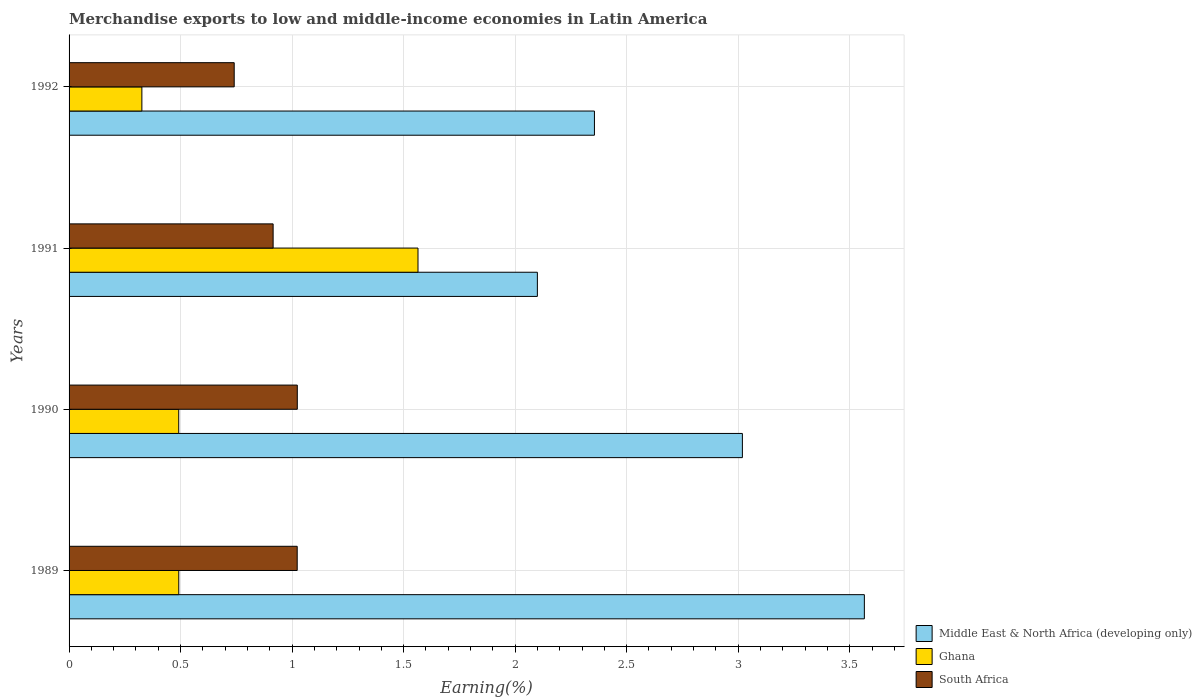Are the number of bars per tick equal to the number of legend labels?
Keep it short and to the point. Yes. Are the number of bars on each tick of the Y-axis equal?
Provide a succinct answer. Yes. How many bars are there on the 4th tick from the bottom?
Ensure brevity in your answer.  3. In how many cases, is the number of bars for a given year not equal to the number of legend labels?
Offer a terse response. 0. What is the percentage of amount earned from merchandise exports in South Africa in 1990?
Provide a short and direct response. 1.02. Across all years, what is the maximum percentage of amount earned from merchandise exports in South Africa?
Provide a succinct answer. 1.02. Across all years, what is the minimum percentage of amount earned from merchandise exports in Ghana?
Make the answer very short. 0.33. In which year was the percentage of amount earned from merchandise exports in South Africa maximum?
Provide a succinct answer. 1990. In which year was the percentage of amount earned from merchandise exports in Middle East & North Africa (developing only) minimum?
Make the answer very short. 1991. What is the total percentage of amount earned from merchandise exports in Ghana in the graph?
Ensure brevity in your answer.  2.87. What is the difference between the percentage of amount earned from merchandise exports in Middle East & North Africa (developing only) in 1989 and that in 1991?
Your answer should be compact. 1.47. What is the difference between the percentage of amount earned from merchandise exports in Ghana in 1992 and the percentage of amount earned from merchandise exports in South Africa in 1991?
Offer a very short reply. -0.59. What is the average percentage of amount earned from merchandise exports in Middle East & North Africa (developing only) per year?
Ensure brevity in your answer.  2.76. In the year 1992, what is the difference between the percentage of amount earned from merchandise exports in South Africa and percentage of amount earned from merchandise exports in Middle East & North Africa (developing only)?
Keep it short and to the point. -1.62. In how many years, is the percentage of amount earned from merchandise exports in Ghana greater than 3.3 %?
Provide a short and direct response. 0. What is the ratio of the percentage of amount earned from merchandise exports in Ghana in 1989 to that in 1990?
Provide a short and direct response. 1. Is the percentage of amount earned from merchandise exports in Ghana in 1989 less than that in 1992?
Make the answer very short. No. Is the difference between the percentage of amount earned from merchandise exports in South Africa in 1991 and 1992 greater than the difference between the percentage of amount earned from merchandise exports in Middle East & North Africa (developing only) in 1991 and 1992?
Your answer should be compact. Yes. What is the difference between the highest and the second highest percentage of amount earned from merchandise exports in South Africa?
Offer a very short reply. 0. What is the difference between the highest and the lowest percentage of amount earned from merchandise exports in South Africa?
Keep it short and to the point. 0.28. Is the sum of the percentage of amount earned from merchandise exports in Middle East & North Africa (developing only) in 1990 and 1991 greater than the maximum percentage of amount earned from merchandise exports in South Africa across all years?
Make the answer very short. Yes. What does the 1st bar from the top in 1990 represents?
Your answer should be compact. South Africa. What does the 3rd bar from the bottom in 1992 represents?
Offer a terse response. South Africa. Is it the case that in every year, the sum of the percentage of amount earned from merchandise exports in Ghana and percentage of amount earned from merchandise exports in Middle East & North Africa (developing only) is greater than the percentage of amount earned from merchandise exports in South Africa?
Offer a very short reply. Yes. Are all the bars in the graph horizontal?
Your answer should be very brief. Yes. How are the legend labels stacked?
Your response must be concise. Vertical. What is the title of the graph?
Keep it short and to the point. Merchandise exports to low and middle-income economies in Latin America. Does "Ukraine" appear as one of the legend labels in the graph?
Ensure brevity in your answer.  No. What is the label or title of the X-axis?
Give a very brief answer. Earning(%). What is the label or title of the Y-axis?
Your response must be concise. Years. What is the Earning(%) in Middle East & North Africa (developing only) in 1989?
Give a very brief answer. 3.57. What is the Earning(%) of Ghana in 1989?
Make the answer very short. 0.49. What is the Earning(%) in South Africa in 1989?
Offer a very short reply. 1.02. What is the Earning(%) of Middle East & North Africa (developing only) in 1990?
Your answer should be very brief. 3.02. What is the Earning(%) of Ghana in 1990?
Provide a succinct answer. 0.49. What is the Earning(%) in South Africa in 1990?
Keep it short and to the point. 1.02. What is the Earning(%) of Middle East & North Africa (developing only) in 1991?
Provide a succinct answer. 2.1. What is the Earning(%) in Ghana in 1991?
Provide a short and direct response. 1.56. What is the Earning(%) of South Africa in 1991?
Keep it short and to the point. 0.91. What is the Earning(%) of Middle East & North Africa (developing only) in 1992?
Offer a terse response. 2.36. What is the Earning(%) in Ghana in 1992?
Provide a succinct answer. 0.33. What is the Earning(%) in South Africa in 1992?
Your answer should be compact. 0.74. Across all years, what is the maximum Earning(%) in Middle East & North Africa (developing only)?
Offer a terse response. 3.57. Across all years, what is the maximum Earning(%) in Ghana?
Keep it short and to the point. 1.56. Across all years, what is the maximum Earning(%) of South Africa?
Make the answer very short. 1.02. Across all years, what is the minimum Earning(%) in Middle East & North Africa (developing only)?
Provide a succinct answer. 2.1. Across all years, what is the minimum Earning(%) of Ghana?
Ensure brevity in your answer.  0.33. Across all years, what is the minimum Earning(%) in South Africa?
Give a very brief answer. 0.74. What is the total Earning(%) in Middle East & North Africa (developing only) in the graph?
Keep it short and to the point. 11.04. What is the total Earning(%) in Ghana in the graph?
Keep it short and to the point. 2.87. What is the total Earning(%) of South Africa in the graph?
Your answer should be very brief. 3.7. What is the difference between the Earning(%) in Middle East & North Africa (developing only) in 1989 and that in 1990?
Your answer should be very brief. 0.55. What is the difference between the Earning(%) of Ghana in 1989 and that in 1990?
Offer a very short reply. 0. What is the difference between the Earning(%) of South Africa in 1989 and that in 1990?
Keep it short and to the point. -0. What is the difference between the Earning(%) of Middle East & North Africa (developing only) in 1989 and that in 1991?
Offer a very short reply. 1.47. What is the difference between the Earning(%) of Ghana in 1989 and that in 1991?
Keep it short and to the point. -1.07. What is the difference between the Earning(%) in South Africa in 1989 and that in 1991?
Ensure brevity in your answer.  0.11. What is the difference between the Earning(%) of Middle East & North Africa (developing only) in 1989 and that in 1992?
Your answer should be very brief. 1.21. What is the difference between the Earning(%) in Ghana in 1989 and that in 1992?
Provide a short and direct response. 0.17. What is the difference between the Earning(%) of South Africa in 1989 and that in 1992?
Ensure brevity in your answer.  0.28. What is the difference between the Earning(%) of Middle East & North Africa (developing only) in 1990 and that in 1991?
Make the answer very short. 0.92. What is the difference between the Earning(%) in Ghana in 1990 and that in 1991?
Give a very brief answer. -1.07. What is the difference between the Earning(%) of South Africa in 1990 and that in 1991?
Keep it short and to the point. 0.11. What is the difference between the Earning(%) of Middle East & North Africa (developing only) in 1990 and that in 1992?
Provide a succinct answer. 0.66. What is the difference between the Earning(%) in Ghana in 1990 and that in 1992?
Provide a short and direct response. 0.17. What is the difference between the Earning(%) in South Africa in 1990 and that in 1992?
Provide a short and direct response. 0.28. What is the difference between the Earning(%) in Middle East & North Africa (developing only) in 1991 and that in 1992?
Make the answer very short. -0.26. What is the difference between the Earning(%) of Ghana in 1991 and that in 1992?
Make the answer very short. 1.24. What is the difference between the Earning(%) in South Africa in 1991 and that in 1992?
Ensure brevity in your answer.  0.17. What is the difference between the Earning(%) of Middle East & North Africa (developing only) in 1989 and the Earning(%) of Ghana in 1990?
Your answer should be very brief. 3.07. What is the difference between the Earning(%) in Middle East & North Africa (developing only) in 1989 and the Earning(%) in South Africa in 1990?
Provide a short and direct response. 2.54. What is the difference between the Earning(%) in Ghana in 1989 and the Earning(%) in South Africa in 1990?
Provide a short and direct response. -0.53. What is the difference between the Earning(%) of Middle East & North Africa (developing only) in 1989 and the Earning(%) of Ghana in 1991?
Keep it short and to the point. 2. What is the difference between the Earning(%) in Middle East & North Africa (developing only) in 1989 and the Earning(%) in South Africa in 1991?
Give a very brief answer. 2.65. What is the difference between the Earning(%) of Ghana in 1989 and the Earning(%) of South Africa in 1991?
Your answer should be compact. -0.42. What is the difference between the Earning(%) of Middle East & North Africa (developing only) in 1989 and the Earning(%) of Ghana in 1992?
Ensure brevity in your answer.  3.24. What is the difference between the Earning(%) in Middle East & North Africa (developing only) in 1989 and the Earning(%) in South Africa in 1992?
Offer a terse response. 2.83. What is the difference between the Earning(%) in Ghana in 1989 and the Earning(%) in South Africa in 1992?
Offer a very short reply. -0.25. What is the difference between the Earning(%) of Middle East & North Africa (developing only) in 1990 and the Earning(%) of Ghana in 1991?
Offer a terse response. 1.45. What is the difference between the Earning(%) in Middle East & North Africa (developing only) in 1990 and the Earning(%) in South Africa in 1991?
Provide a short and direct response. 2.1. What is the difference between the Earning(%) of Ghana in 1990 and the Earning(%) of South Africa in 1991?
Make the answer very short. -0.42. What is the difference between the Earning(%) in Middle East & North Africa (developing only) in 1990 and the Earning(%) in Ghana in 1992?
Keep it short and to the point. 2.69. What is the difference between the Earning(%) in Middle East & North Africa (developing only) in 1990 and the Earning(%) in South Africa in 1992?
Your answer should be compact. 2.28. What is the difference between the Earning(%) in Ghana in 1990 and the Earning(%) in South Africa in 1992?
Make the answer very short. -0.25. What is the difference between the Earning(%) of Middle East & North Africa (developing only) in 1991 and the Earning(%) of Ghana in 1992?
Offer a very short reply. 1.77. What is the difference between the Earning(%) in Middle East & North Africa (developing only) in 1991 and the Earning(%) in South Africa in 1992?
Provide a succinct answer. 1.36. What is the difference between the Earning(%) in Ghana in 1991 and the Earning(%) in South Africa in 1992?
Offer a very short reply. 0.82. What is the average Earning(%) of Middle East & North Africa (developing only) per year?
Offer a very short reply. 2.76. What is the average Earning(%) in Ghana per year?
Offer a terse response. 0.72. What is the average Earning(%) of South Africa per year?
Your answer should be compact. 0.93. In the year 1989, what is the difference between the Earning(%) in Middle East & North Africa (developing only) and Earning(%) in Ghana?
Provide a succinct answer. 3.07. In the year 1989, what is the difference between the Earning(%) of Middle East & North Africa (developing only) and Earning(%) of South Africa?
Your response must be concise. 2.54. In the year 1989, what is the difference between the Earning(%) of Ghana and Earning(%) of South Africa?
Offer a very short reply. -0.53. In the year 1990, what is the difference between the Earning(%) of Middle East & North Africa (developing only) and Earning(%) of Ghana?
Keep it short and to the point. 2.53. In the year 1990, what is the difference between the Earning(%) of Middle East & North Africa (developing only) and Earning(%) of South Africa?
Provide a succinct answer. 2. In the year 1990, what is the difference between the Earning(%) in Ghana and Earning(%) in South Africa?
Your response must be concise. -0.53. In the year 1991, what is the difference between the Earning(%) in Middle East & North Africa (developing only) and Earning(%) in Ghana?
Keep it short and to the point. 0.54. In the year 1991, what is the difference between the Earning(%) in Middle East & North Africa (developing only) and Earning(%) in South Africa?
Make the answer very short. 1.18. In the year 1991, what is the difference between the Earning(%) in Ghana and Earning(%) in South Africa?
Provide a succinct answer. 0.65. In the year 1992, what is the difference between the Earning(%) of Middle East & North Africa (developing only) and Earning(%) of Ghana?
Provide a short and direct response. 2.03. In the year 1992, what is the difference between the Earning(%) in Middle East & North Africa (developing only) and Earning(%) in South Africa?
Offer a terse response. 1.62. In the year 1992, what is the difference between the Earning(%) in Ghana and Earning(%) in South Africa?
Ensure brevity in your answer.  -0.41. What is the ratio of the Earning(%) of Middle East & North Africa (developing only) in 1989 to that in 1990?
Ensure brevity in your answer.  1.18. What is the ratio of the Earning(%) in Ghana in 1989 to that in 1990?
Offer a very short reply. 1. What is the ratio of the Earning(%) in Middle East & North Africa (developing only) in 1989 to that in 1991?
Provide a succinct answer. 1.7. What is the ratio of the Earning(%) in Ghana in 1989 to that in 1991?
Give a very brief answer. 0.31. What is the ratio of the Earning(%) in South Africa in 1989 to that in 1991?
Ensure brevity in your answer.  1.12. What is the ratio of the Earning(%) in Middle East & North Africa (developing only) in 1989 to that in 1992?
Your response must be concise. 1.51. What is the ratio of the Earning(%) of Ghana in 1989 to that in 1992?
Offer a very short reply. 1.51. What is the ratio of the Earning(%) of South Africa in 1989 to that in 1992?
Your response must be concise. 1.38. What is the ratio of the Earning(%) of Middle East & North Africa (developing only) in 1990 to that in 1991?
Give a very brief answer. 1.44. What is the ratio of the Earning(%) in Ghana in 1990 to that in 1991?
Your answer should be compact. 0.31. What is the ratio of the Earning(%) of South Africa in 1990 to that in 1991?
Make the answer very short. 1.12. What is the ratio of the Earning(%) of Middle East & North Africa (developing only) in 1990 to that in 1992?
Give a very brief answer. 1.28. What is the ratio of the Earning(%) of Ghana in 1990 to that in 1992?
Offer a very short reply. 1.51. What is the ratio of the Earning(%) of South Africa in 1990 to that in 1992?
Your answer should be very brief. 1.38. What is the ratio of the Earning(%) in Middle East & North Africa (developing only) in 1991 to that in 1992?
Ensure brevity in your answer.  0.89. What is the ratio of the Earning(%) of Ghana in 1991 to that in 1992?
Give a very brief answer. 4.79. What is the ratio of the Earning(%) in South Africa in 1991 to that in 1992?
Provide a short and direct response. 1.24. What is the difference between the highest and the second highest Earning(%) in Middle East & North Africa (developing only)?
Give a very brief answer. 0.55. What is the difference between the highest and the second highest Earning(%) of Ghana?
Keep it short and to the point. 1.07. What is the difference between the highest and the lowest Earning(%) in Middle East & North Africa (developing only)?
Your response must be concise. 1.47. What is the difference between the highest and the lowest Earning(%) of Ghana?
Make the answer very short. 1.24. What is the difference between the highest and the lowest Earning(%) in South Africa?
Give a very brief answer. 0.28. 